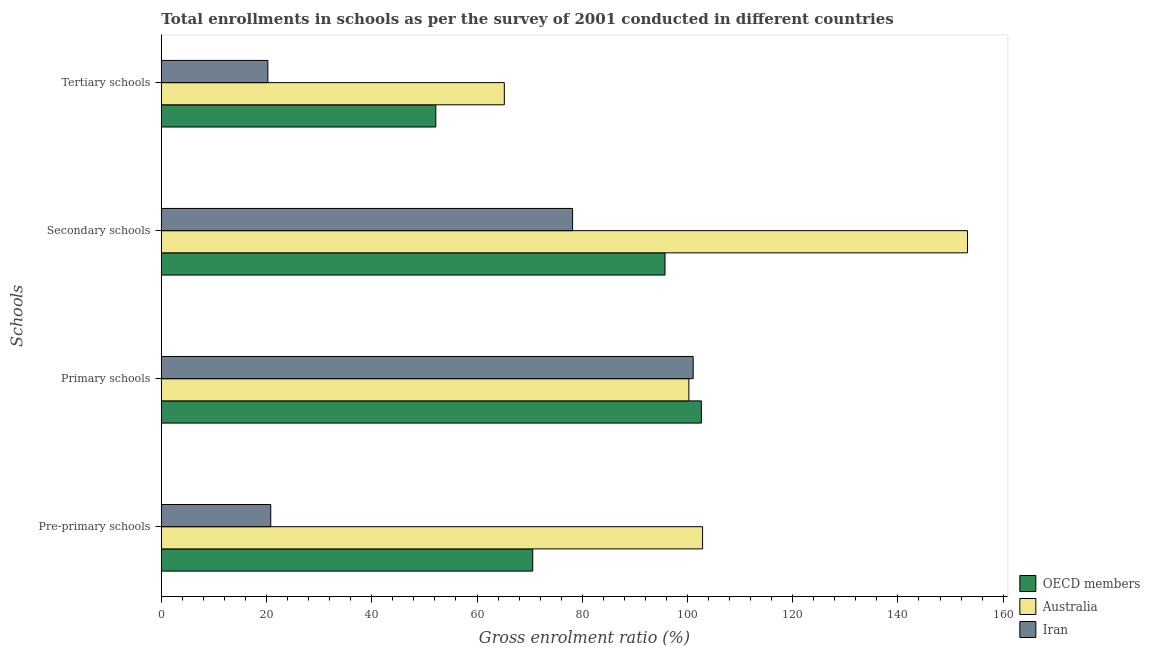How many different coloured bars are there?
Your answer should be very brief. 3. How many groups of bars are there?
Offer a terse response. 4. Are the number of bars on each tick of the Y-axis equal?
Your response must be concise. Yes. How many bars are there on the 4th tick from the top?
Give a very brief answer. 3. What is the label of the 4th group of bars from the top?
Give a very brief answer. Pre-primary schools. What is the gross enrolment ratio in pre-primary schools in Australia?
Ensure brevity in your answer.  102.87. Across all countries, what is the maximum gross enrolment ratio in secondary schools?
Your answer should be very brief. 153.22. Across all countries, what is the minimum gross enrolment ratio in secondary schools?
Offer a terse response. 78.16. In which country was the gross enrolment ratio in tertiary schools minimum?
Offer a very short reply. Iran. What is the total gross enrolment ratio in pre-primary schools in the graph?
Your answer should be compact. 194.26. What is the difference between the gross enrolment ratio in secondary schools in Iran and that in Australia?
Your answer should be compact. -75.06. What is the difference between the gross enrolment ratio in secondary schools in Iran and the gross enrolment ratio in primary schools in Australia?
Offer a very short reply. -22.1. What is the average gross enrolment ratio in pre-primary schools per country?
Your answer should be compact. 64.75. What is the difference between the gross enrolment ratio in primary schools and gross enrolment ratio in secondary schools in OECD members?
Offer a very short reply. 6.91. What is the ratio of the gross enrolment ratio in primary schools in Iran to that in OECD members?
Ensure brevity in your answer.  0.98. Is the gross enrolment ratio in secondary schools in Iran less than that in Australia?
Offer a terse response. Yes. Is the difference between the gross enrolment ratio in primary schools in OECD members and Iran greater than the difference between the gross enrolment ratio in pre-primary schools in OECD members and Iran?
Provide a succinct answer. No. What is the difference between the highest and the second highest gross enrolment ratio in pre-primary schools?
Make the answer very short. 32.28. What is the difference between the highest and the lowest gross enrolment ratio in secondary schools?
Your answer should be very brief. 75.06. In how many countries, is the gross enrolment ratio in secondary schools greater than the average gross enrolment ratio in secondary schools taken over all countries?
Provide a succinct answer. 1. Is the sum of the gross enrolment ratio in tertiary schools in Iran and OECD members greater than the maximum gross enrolment ratio in pre-primary schools across all countries?
Offer a terse response. No. Is it the case that in every country, the sum of the gross enrolment ratio in pre-primary schools and gross enrolment ratio in tertiary schools is greater than the sum of gross enrolment ratio in primary schools and gross enrolment ratio in secondary schools?
Give a very brief answer. No. What does the 3rd bar from the top in Tertiary schools represents?
Provide a succinct answer. OECD members. How many countries are there in the graph?
Provide a short and direct response. 3. What is the difference between two consecutive major ticks on the X-axis?
Provide a succinct answer. 20. Does the graph contain grids?
Your answer should be compact. No. Where does the legend appear in the graph?
Keep it short and to the point. Bottom right. How many legend labels are there?
Give a very brief answer. 3. How are the legend labels stacked?
Give a very brief answer. Vertical. What is the title of the graph?
Offer a terse response. Total enrollments in schools as per the survey of 2001 conducted in different countries. What is the label or title of the X-axis?
Keep it short and to the point. Gross enrolment ratio (%). What is the label or title of the Y-axis?
Provide a succinct answer. Schools. What is the Gross enrolment ratio (%) of OECD members in Pre-primary schools?
Provide a succinct answer. 70.59. What is the Gross enrolment ratio (%) in Australia in Pre-primary schools?
Offer a terse response. 102.87. What is the Gross enrolment ratio (%) of Iran in Pre-primary schools?
Ensure brevity in your answer.  20.8. What is the Gross enrolment ratio (%) in OECD members in Primary schools?
Your answer should be compact. 102.64. What is the Gross enrolment ratio (%) in Australia in Primary schools?
Your response must be concise. 100.26. What is the Gross enrolment ratio (%) of Iran in Primary schools?
Offer a terse response. 101.08. What is the Gross enrolment ratio (%) in OECD members in Secondary schools?
Make the answer very short. 95.73. What is the Gross enrolment ratio (%) in Australia in Secondary schools?
Offer a terse response. 153.22. What is the Gross enrolment ratio (%) in Iran in Secondary schools?
Give a very brief answer. 78.16. What is the Gross enrolment ratio (%) of OECD members in Tertiary schools?
Provide a succinct answer. 52.17. What is the Gross enrolment ratio (%) of Australia in Tertiary schools?
Ensure brevity in your answer.  65.19. What is the Gross enrolment ratio (%) in Iran in Tertiary schools?
Give a very brief answer. 20.25. Across all Schools, what is the maximum Gross enrolment ratio (%) of OECD members?
Provide a short and direct response. 102.64. Across all Schools, what is the maximum Gross enrolment ratio (%) in Australia?
Give a very brief answer. 153.22. Across all Schools, what is the maximum Gross enrolment ratio (%) in Iran?
Offer a terse response. 101.08. Across all Schools, what is the minimum Gross enrolment ratio (%) in OECD members?
Keep it short and to the point. 52.17. Across all Schools, what is the minimum Gross enrolment ratio (%) in Australia?
Keep it short and to the point. 65.19. Across all Schools, what is the minimum Gross enrolment ratio (%) in Iran?
Make the answer very short. 20.25. What is the total Gross enrolment ratio (%) in OECD members in the graph?
Your answer should be very brief. 321.14. What is the total Gross enrolment ratio (%) in Australia in the graph?
Your answer should be compact. 421.55. What is the total Gross enrolment ratio (%) in Iran in the graph?
Your answer should be compact. 220.29. What is the difference between the Gross enrolment ratio (%) in OECD members in Pre-primary schools and that in Primary schools?
Your response must be concise. -32.05. What is the difference between the Gross enrolment ratio (%) of Australia in Pre-primary schools and that in Primary schools?
Provide a succinct answer. 2.61. What is the difference between the Gross enrolment ratio (%) of Iran in Pre-primary schools and that in Primary schools?
Your answer should be compact. -80.29. What is the difference between the Gross enrolment ratio (%) in OECD members in Pre-primary schools and that in Secondary schools?
Offer a terse response. -25.14. What is the difference between the Gross enrolment ratio (%) of Australia in Pre-primary schools and that in Secondary schools?
Ensure brevity in your answer.  -50.35. What is the difference between the Gross enrolment ratio (%) in Iran in Pre-primary schools and that in Secondary schools?
Offer a very short reply. -57.36. What is the difference between the Gross enrolment ratio (%) of OECD members in Pre-primary schools and that in Tertiary schools?
Offer a terse response. 18.42. What is the difference between the Gross enrolment ratio (%) in Australia in Pre-primary schools and that in Tertiary schools?
Provide a succinct answer. 37.68. What is the difference between the Gross enrolment ratio (%) of Iran in Pre-primary schools and that in Tertiary schools?
Provide a short and direct response. 0.55. What is the difference between the Gross enrolment ratio (%) in OECD members in Primary schools and that in Secondary schools?
Provide a short and direct response. 6.91. What is the difference between the Gross enrolment ratio (%) of Australia in Primary schools and that in Secondary schools?
Your answer should be very brief. -52.96. What is the difference between the Gross enrolment ratio (%) in Iran in Primary schools and that in Secondary schools?
Keep it short and to the point. 22.92. What is the difference between the Gross enrolment ratio (%) of OECD members in Primary schools and that in Tertiary schools?
Your response must be concise. 50.47. What is the difference between the Gross enrolment ratio (%) in Australia in Primary schools and that in Tertiary schools?
Your answer should be very brief. 35.07. What is the difference between the Gross enrolment ratio (%) in Iran in Primary schools and that in Tertiary schools?
Give a very brief answer. 80.84. What is the difference between the Gross enrolment ratio (%) in OECD members in Secondary schools and that in Tertiary schools?
Give a very brief answer. 43.56. What is the difference between the Gross enrolment ratio (%) in Australia in Secondary schools and that in Tertiary schools?
Keep it short and to the point. 88.03. What is the difference between the Gross enrolment ratio (%) in Iran in Secondary schools and that in Tertiary schools?
Your answer should be compact. 57.92. What is the difference between the Gross enrolment ratio (%) of OECD members in Pre-primary schools and the Gross enrolment ratio (%) of Australia in Primary schools?
Make the answer very short. -29.67. What is the difference between the Gross enrolment ratio (%) of OECD members in Pre-primary schools and the Gross enrolment ratio (%) of Iran in Primary schools?
Offer a very short reply. -30.49. What is the difference between the Gross enrolment ratio (%) in Australia in Pre-primary schools and the Gross enrolment ratio (%) in Iran in Primary schools?
Make the answer very short. 1.78. What is the difference between the Gross enrolment ratio (%) in OECD members in Pre-primary schools and the Gross enrolment ratio (%) in Australia in Secondary schools?
Offer a very short reply. -82.63. What is the difference between the Gross enrolment ratio (%) in OECD members in Pre-primary schools and the Gross enrolment ratio (%) in Iran in Secondary schools?
Your response must be concise. -7.57. What is the difference between the Gross enrolment ratio (%) of Australia in Pre-primary schools and the Gross enrolment ratio (%) of Iran in Secondary schools?
Offer a terse response. 24.71. What is the difference between the Gross enrolment ratio (%) in OECD members in Pre-primary schools and the Gross enrolment ratio (%) in Australia in Tertiary schools?
Provide a short and direct response. 5.4. What is the difference between the Gross enrolment ratio (%) in OECD members in Pre-primary schools and the Gross enrolment ratio (%) in Iran in Tertiary schools?
Ensure brevity in your answer.  50.35. What is the difference between the Gross enrolment ratio (%) in Australia in Pre-primary schools and the Gross enrolment ratio (%) in Iran in Tertiary schools?
Your answer should be very brief. 82.62. What is the difference between the Gross enrolment ratio (%) of OECD members in Primary schools and the Gross enrolment ratio (%) of Australia in Secondary schools?
Ensure brevity in your answer.  -50.58. What is the difference between the Gross enrolment ratio (%) of OECD members in Primary schools and the Gross enrolment ratio (%) of Iran in Secondary schools?
Offer a terse response. 24.48. What is the difference between the Gross enrolment ratio (%) in Australia in Primary schools and the Gross enrolment ratio (%) in Iran in Secondary schools?
Ensure brevity in your answer.  22.1. What is the difference between the Gross enrolment ratio (%) in OECD members in Primary schools and the Gross enrolment ratio (%) in Australia in Tertiary schools?
Give a very brief answer. 37.45. What is the difference between the Gross enrolment ratio (%) in OECD members in Primary schools and the Gross enrolment ratio (%) in Iran in Tertiary schools?
Offer a very short reply. 82.4. What is the difference between the Gross enrolment ratio (%) in Australia in Primary schools and the Gross enrolment ratio (%) in Iran in Tertiary schools?
Offer a very short reply. 80.02. What is the difference between the Gross enrolment ratio (%) of OECD members in Secondary schools and the Gross enrolment ratio (%) of Australia in Tertiary schools?
Provide a short and direct response. 30.54. What is the difference between the Gross enrolment ratio (%) in OECD members in Secondary schools and the Gross enrolment ratio (%) in Iran in Tertiary schools?
Ensure brevity in your answer.  75.48. What is the difference between the Gross enrolment ratio (%) of Australia in Secondary schools and the Gross enrolment ratio (%) of Iran in Tertiary schools?
Your answer should be compact. 132.98. What is the average Gross enrolment ratio (%) in OECD members per Schools?
Give a very brief answer. 80.28. What is the average Gross enrolment ratio (%) in Australia per Schools?
Make the answer very short. 105.39. What is the average Gross enrolment ratio (%) in Iran per Schools?
Your response must be concise. 55.07. What is the difference between the Gross enrolment ratio (%) of OECD members and Gross enrolment ratio (%) of Australia in Pre-primary schools?
Your answer should be very brief. -32.28. What is the difference between the Gross enrolment ratio (%) in OECD members and Gross enrolment ratio (%) in Iran in Pre-primary schools?
Offer a terse response. 49.79. What is the difference between the Gross enrolment ratio (%) in Australia and Gross enrolment ratio (%) in Iran in Pre-primary schools?
Ensure brevity in your answer.  82.07. What is the difference between the Gross enrolment ratio (%) of OECD members and Gross enrolment ratio (%) of Australia in Primary schools?
Your answer should be compact. 2.38. What is the difference between the Gross enrolment ratio (%) in OECD members and Gross enrolment ratio (%) in Iran in Primary schools?
Your answer should be compact. 1.56. What is the difference between the Gross enrolment ratio (%) in Australia and Gross enrolment ratio (%) in Iran in Primary schools?
Make the answer very short. -0.82. What is the difference between the Gross enrolment ratio (%) of OECD members and Gross enrolment ratio (%) of Australia in Secondary schools?
Ensure brevity in your answer.  -57.49. What is the difference between the Gross enrolment ratio (%) of OECD members and Gross enrolment ratio (%) of Iran in Secondary schools?
Make the answer very short. 17.57. What is the difference between the Gross enrolment ratio (%) of Australia and Gross enrolment ratio (%) of Iran in Secondary schools?
Give a very brief answer. 75.06. What is the difference between the Gross enrolment ratio (%) in OECD members and Gross enrolment ratio (%) in Australia in Tertiary schools?
Keep it short and to the point. -13.02. What is the difference between the Gross enrolment ratio (%) of OECD members and Gross enrolment ratio (%) of Iran in Tertiary schools?
Provide a succinct answer. 31.92. What is the difference between the Gross enrolment ratio (%) of Australia and Gross enrolment ratio (%) of Iran in Tertiary schools?
Your answer should be very brief. 44.95. What is the ratio of the Gross enrolment ratio (%) in OECD members in Pre-primary schools to that in Primary schools?
Make the answer very short. 0.69. What is the ratio of the Gross enrolment ratio (%) of Australia in Pre-primary schools to that in Primary schools?
Your answer should be compact. 1.03. What is the ratio of the Gross enrolment ratio (%) of Iran in Pre-primary schools to that in Primary schools?
Ensure brevity in your answer.  0.21. What is the ratio of the Gross enrolment ratio (%) of OECD members in Pre-primary schools to that in Secondary schools?
Ensure brevity in your answer.  0.74. What is the ratio of the Gross enrolment ratio (%) in Australia in Pre-primary schools to that in Secondary schools?
Your answer should be very brief. 0.67. What is the ratio of the Gross enrolment ratio (%) of Iran in Pre-primary schools to that in Secondary schools?
Your answer should be compact. 0.27. What is the ratio of the Gross enrolment ratio (%) of OECD members in Pre-primary schools to that in Tertiary schools?
Ensure brevity in your answer.  1.35. What is the ratio of the Gross enrolment ratio (%) in Australia in Pre-primary schools to that in Tertiary schools?
Provide a succinct answer. 1.58. What is the ratio of the Gross enrolment ratio (%) in Iran in Pre-primary schools to that in Tertiary schools?
Offer a terse response. 1.03. What is the ratio of the Gross enrolment ratio (%) of OECD members in Primary schools to that in Secondary schools?
Make the answer very short. 1.07. What is the ratio of the Gross enrolment ratio (%) in Australia in Primary schools to that in Secondary schools?
Offer a terse response. 0.65. What is the ratio of the Gross enrolment ratio (%) in Iran in Primary schools to that in Secondary schools?
Offer a terse response. 1.29. What is the ratio of the Gross enrolment ratio (%) of OECD members in Primary schools to that in Tertiary schools?
Give a very brief answer. 1.97. What is the ratio of the Gross enrolment ratio (%) in Australia in Primary schools to that in Tertiary schools?
Provide a succinct answer. 1.54. What is the ratio of the Gross enrolment ratio (%) in Iran in Primary schools to that in Tertiary schools?
Offer a very short reply. 4.99. What is the ratio of the Gross enrolment ratio (%) in OECD members in Secondary schools to that in Tertiary schools?
Keep it short and to the point. 1.83. What is the ratio of the Gross enrolment ratio (%) in Australia in Secondary schools to that in Tertiary schools?
Provide a short and direct response. 2.35. What is the ratio of the Gross enrolment ratio (%) of Iran in Secondary schools to that in Tertiary schools?
Provide a short and direct response. 3.86. What is the difference between the highest and the second highest Gross enrolment ratio (%) in OECD members?
Your answer should be very brief. 6.91. What is the difference between the highest and the second highest Gross enrolment ratio (%) in Australia?
Your answer should be very brief. 50.35. What is the difference between the highest and the second highest Gross enrolment ratio (%) of Iran?
Give a very brief answer. 22.92. What is the difference between the highest and the lowest Gross enrolment ratio (%) of OECD members?
Your answer should be very brief. 50.47. What is the difference between the highest and the lowest Gross enrolment ratio (%) in Australia?
Your answer should be very brief. 88.03. What is the difference between the highest and the lowest Gross enrolment ratio (%) in Iran?
Your answer should be very brief. 80.84. 